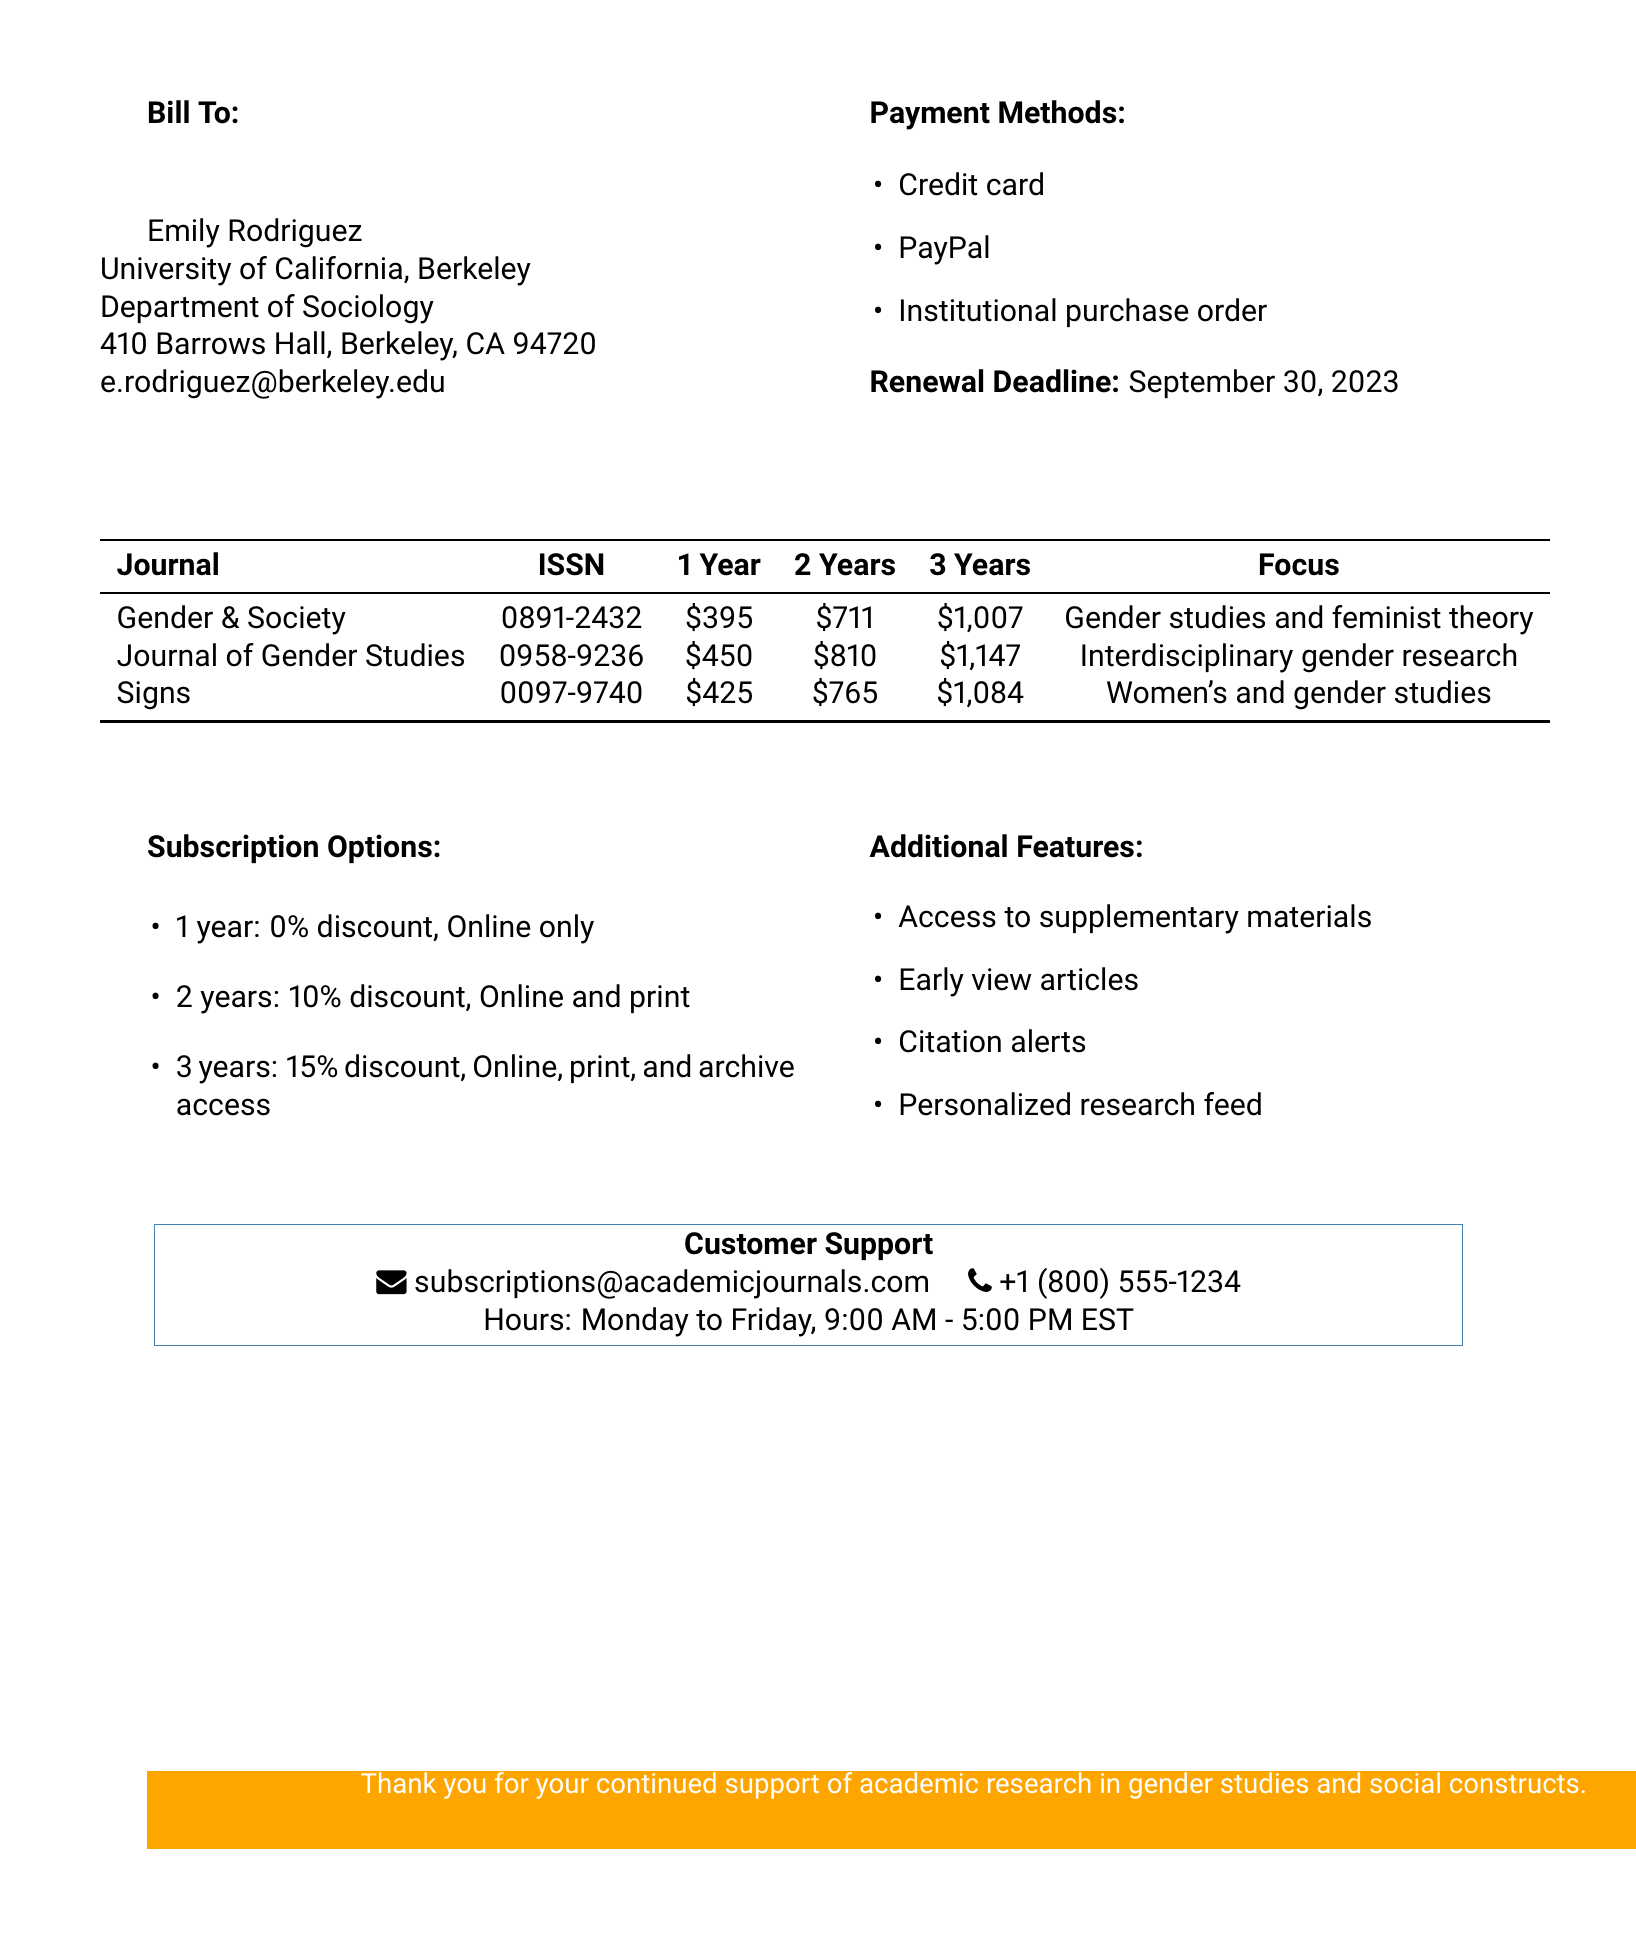What is the name of the first journal listed? The document lists "Gender & Society" as the first journal in the journal details section.
Answer: Gender & Society What is the total cost of a 3-year subscription to "Journal of Gender Studies"? The document states the price for a 3-year subscription to "Journal of Gender Studies" is $1,147.
Answer: $1,147 What discount is offered for a 2-year subscription? The subscription options section indicates a 10% discount is available for a 2-year subscription.
Answer: 10% What is the ISSN of "Signs: Journal of Women in Culture and Society"? The document provides the ISSN for "Signs" as 0097-9740.
Answer: 0097-9740 What additional feature allows users to track new citations? The document lists "Citation alerts" as one of the additional features available with the subscriptions.
Answer: Citation alerts What is the renewal deadline date? The renewal deadline specified in the document is September 30, 2023.
Answer: September 30, 2023 How many payment options are listed? The document enumerates three payment methods under the payment methods section, so it indicates that there are three options available.
Answer: 3 What is the price for a 1-year subscription to "Gender & Society"? The document states that the price for a 1-year subscription to "Gender & Society" is $395.
Answer: $395 